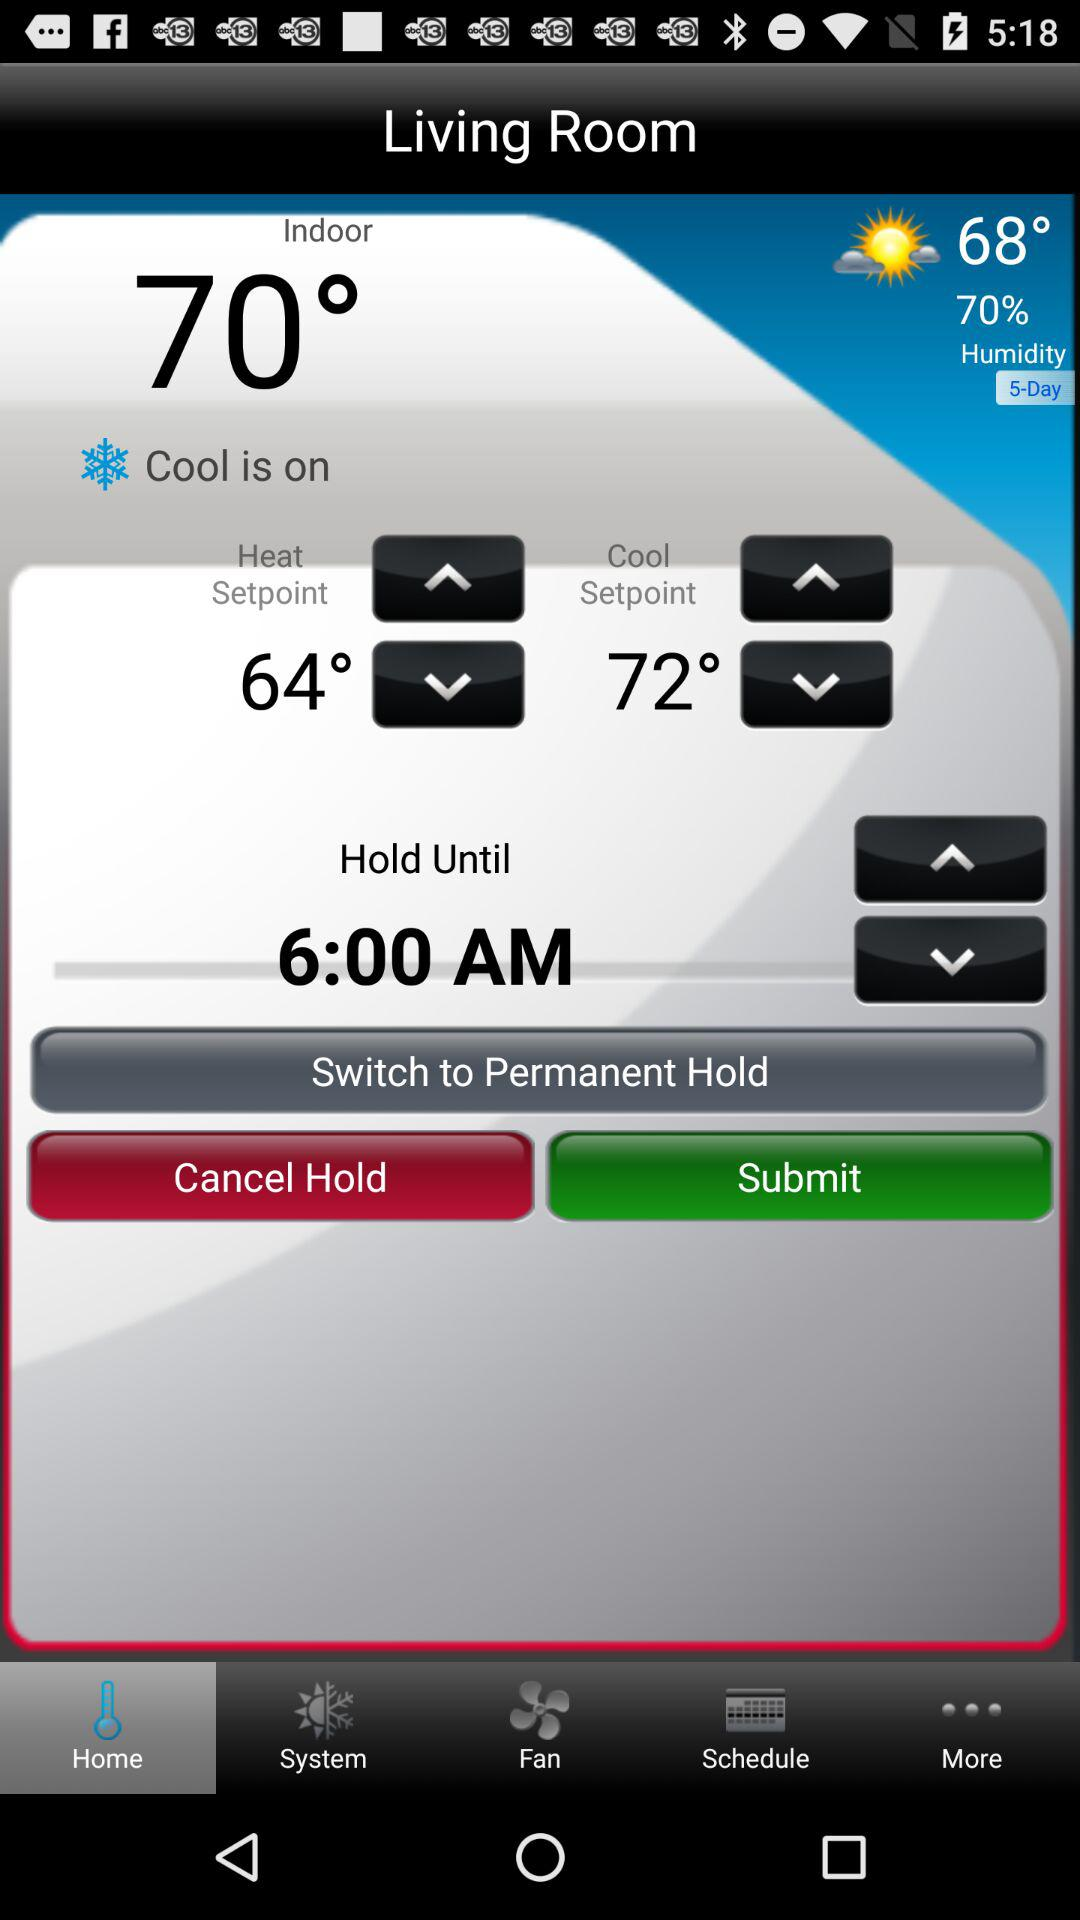What is the heat setpoint? The heat setpoint is 64°. 